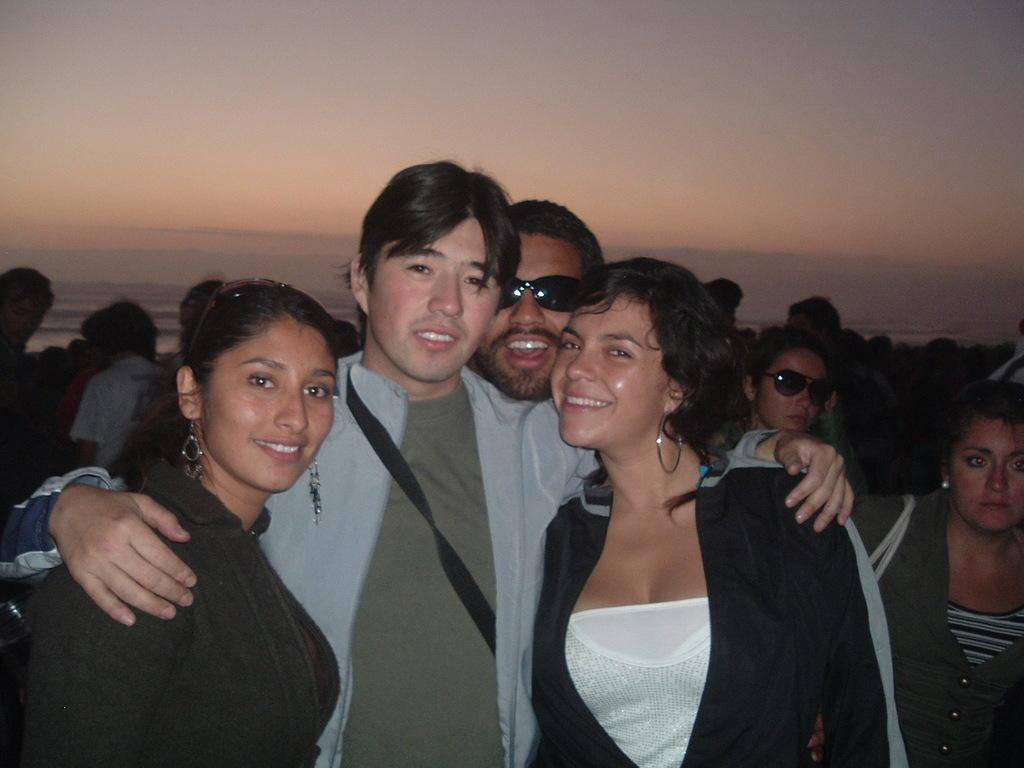How many people are present in the image? There are many people in the image. Can you describe any specific features of the people in the image? Some of the people are wearing glasses. What is one person wearing in the image? One person is wearing a bag. What can be seen in the background of the image? The sky is visible in the background of the image. What type of creature is sitting on the person's shoulder in the image? There is no creature present on anyone's shoulder in the image. Can you tell me the title of the book one of the people is reading in the image? There is no book visible in the image, so it is not possible to determine the title. 